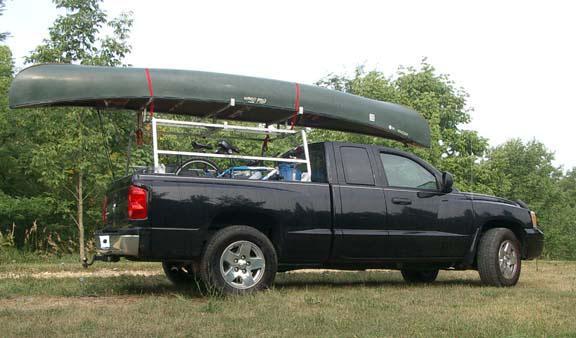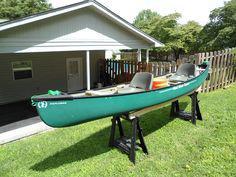The first image is the image on the left, the second image is the image on the right. Analyze the images presented: Is the assertion "One of the boats is green." valid? Answer yes or no. Yes. 